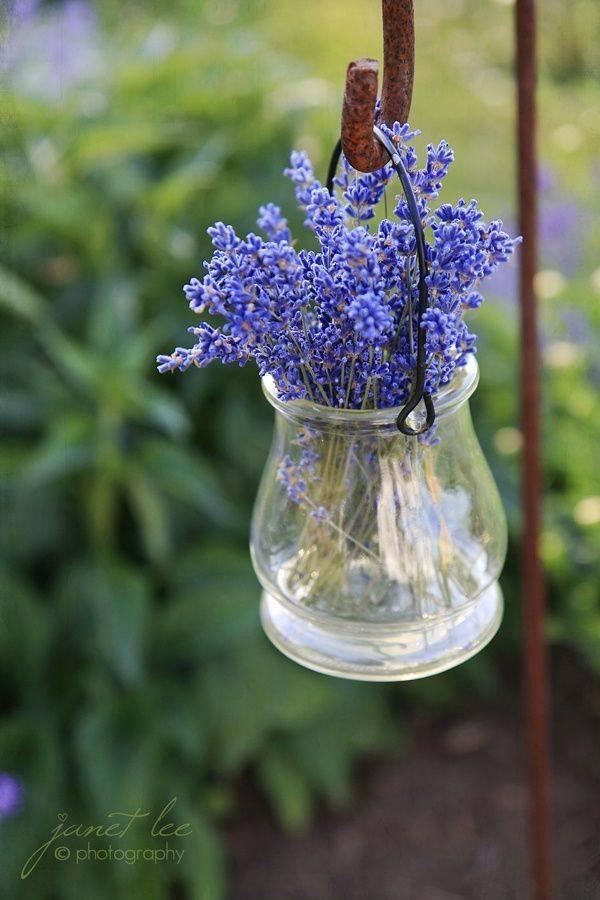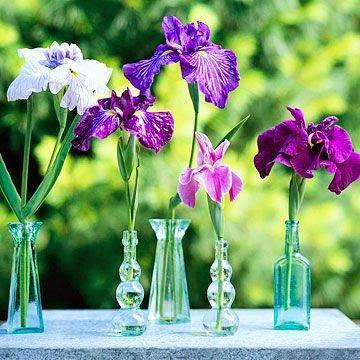The first image is the image on the left, the second image is the image on the right. Evaluate the accuracy of this statement regarding the images: "At least one vase is hanging.". Is it true? Answer yes or no. Yes. 